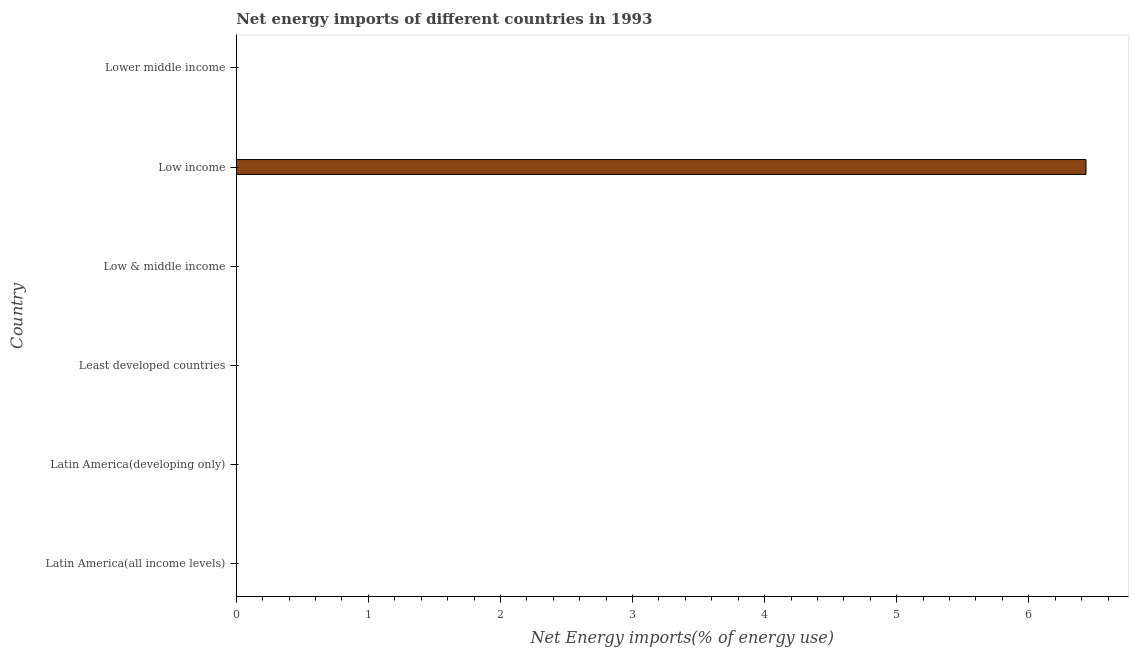Does the graph contain any zero values?
Your answer should be compact. Yes. Does the graph contain grids?
Offer a terse response. No. What is the title of the graph?
Give a very brief answer. Net energy imports of different countries in 1993. What is the label or title of the X-axis?
Provide a short and direct response. Net Energy imports(% of energy use). Across all countries, what is the maximum energy imports?
Offer a terse response. 6.43. Across all countries, what is the minimum energy imports?
Your answer should be very brief. 0. In which country was the energy imports maximum?
Keep it short and to the point. Low income. What is the sum of the energy imports?
Your response must be concise. 6.43. What is the average energy imports per country?
Offer a very short reply. 1.07. What is the difference between the highest and the lowest energy imports?
Provide a short and direct response. 6.43. How many bars are there?
Keep it short and to the point. 1. What is the Net Energy imports(% of energy use) in Latin America(developing only)?
Make the answer very short. 0. What is the Net Energy imports(% of energy use) in Least developed countries?
Your answer should be very brief. 0. What is the Net Energy imports(% of energy use) in Low & middle income?
Your response must be concise. 0. What is the Net Energy imports(% of energy use) of Low income?
Your answer should be very brief. 6.43. 